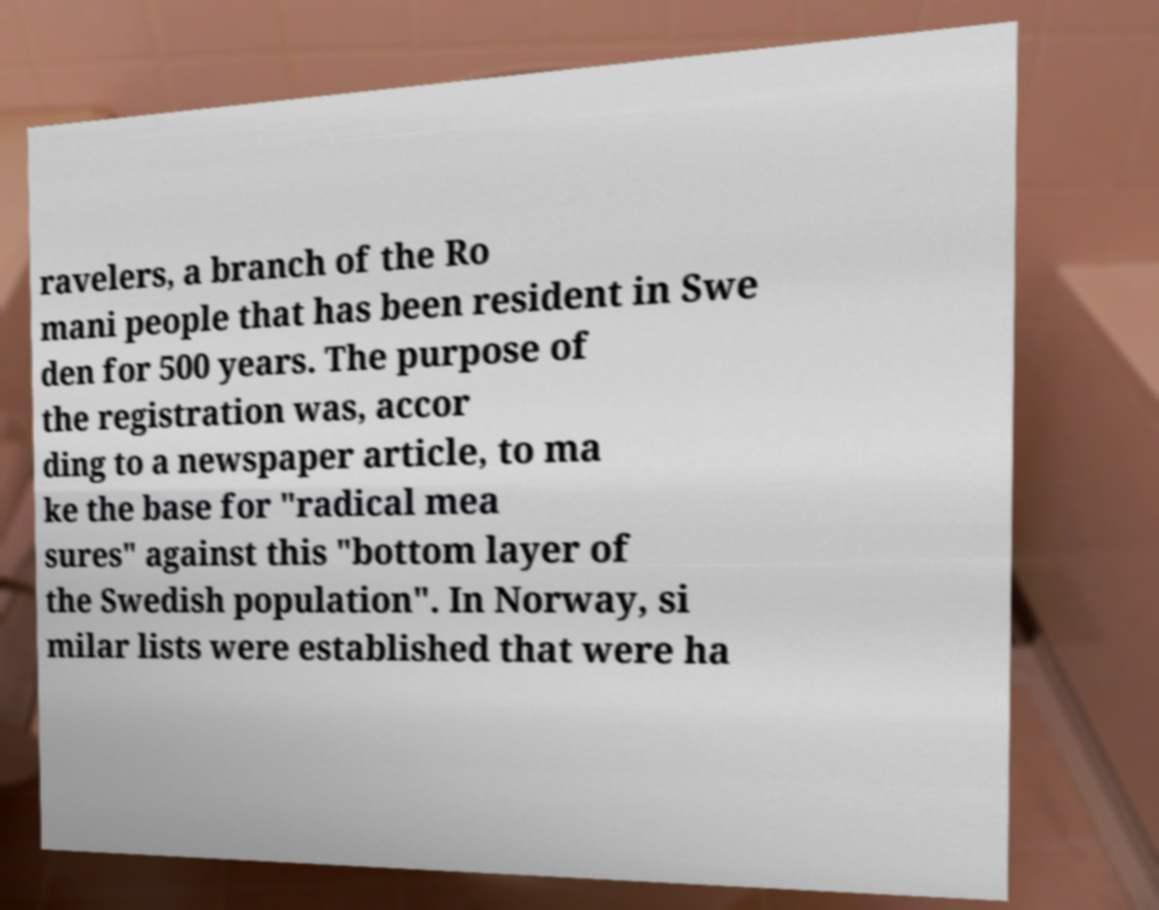There's text embedded in this image that I need extracted. Can you transcribe it verbatim? ravelers, a branch of the Ro mani people that has been resident in Swe den for 500 years. The purpose of the registration was, accor ding to a newspaper article, to ma ke the base for "radical mea sures" against this "bottom layer of the Swedish population". In Norway, si milar lists were established that were ha 